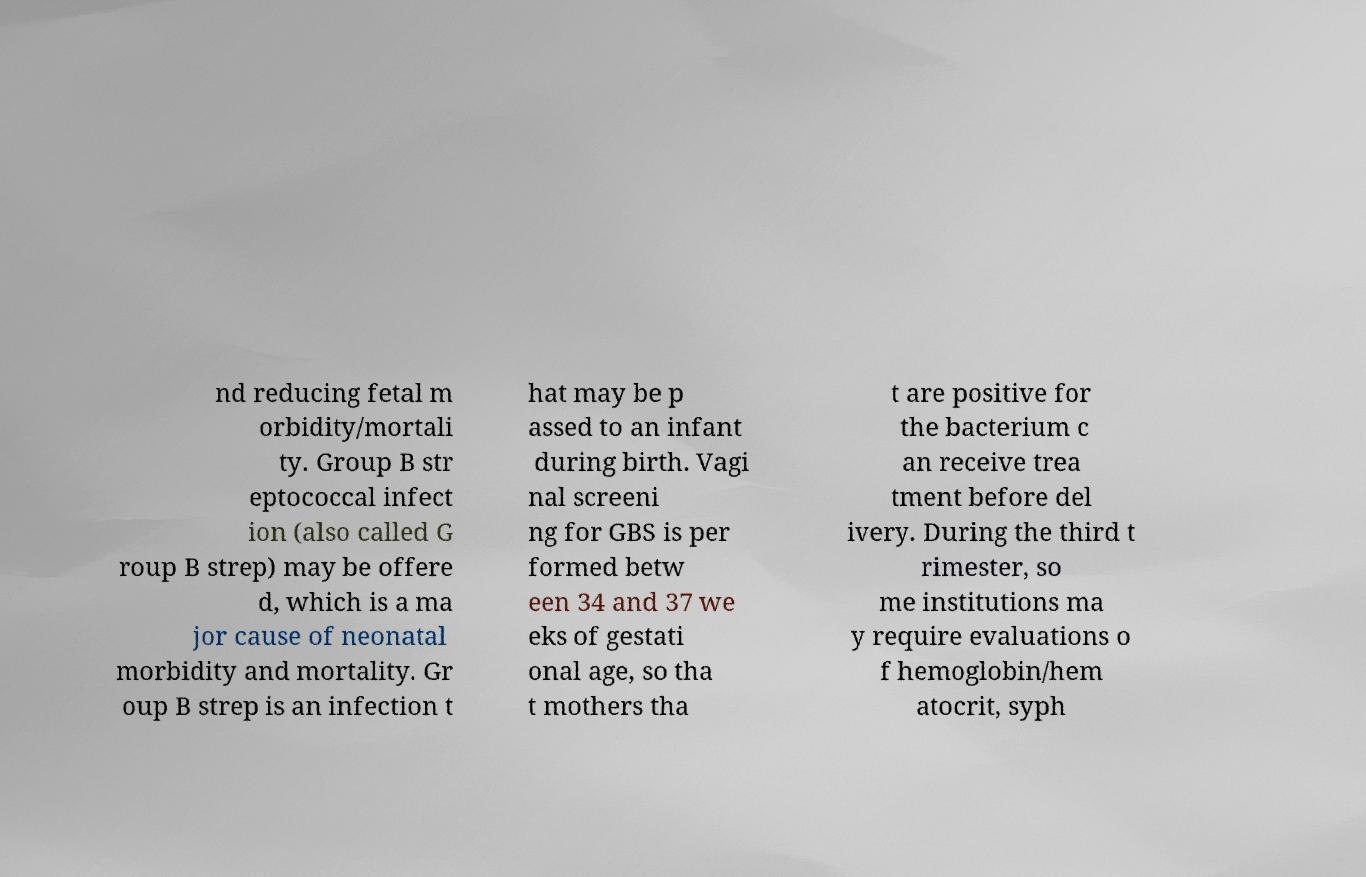Please read and relay the text visible in this image. What does it say? nd reducing fetal m orbidity/mortali ty. Group B str eptococcal infect ion (also called G roup B strep) may be offere d, which is a ma jor cause of neonatal morbidity and mortality. Gr oup B strep is an infection t hat may be p assed to an infant during birth. Vagi nal screeni ng for GBS is per formed betw een 34 and 37 we eks of gestati onal age, so tha t mothers tha t are positive for the bacterium c an receive trea tment before del ivery. During the third t rimester, so me institutions ma y require evaluations o f hemoglobin/hem atocrit, syph 